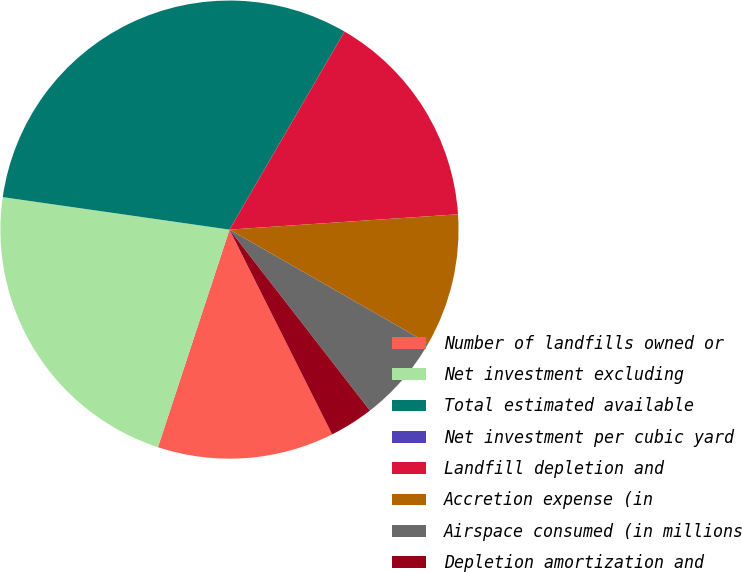Convert chart. <chart><loc_0><loc_0><loc_500><loc_500><pie_chart><fcel>Number of landfills owned or<fcel>Net investment excluding<fcel>Total estimated available<fcel>Net investment per cubic yard<fcel>Landfill depletion and<fcel>Accretion expense (in<fcel>Airspace consumed (in millions<fcel>Depletion amortization and<nl><fcel>12.45%<fcel>22.21%<fcel>31.11%<fcel>0.0%<fcel>15.56%<fcel>9.34%<fcel>6.22%<fcel>3.11%<nl></chart> 